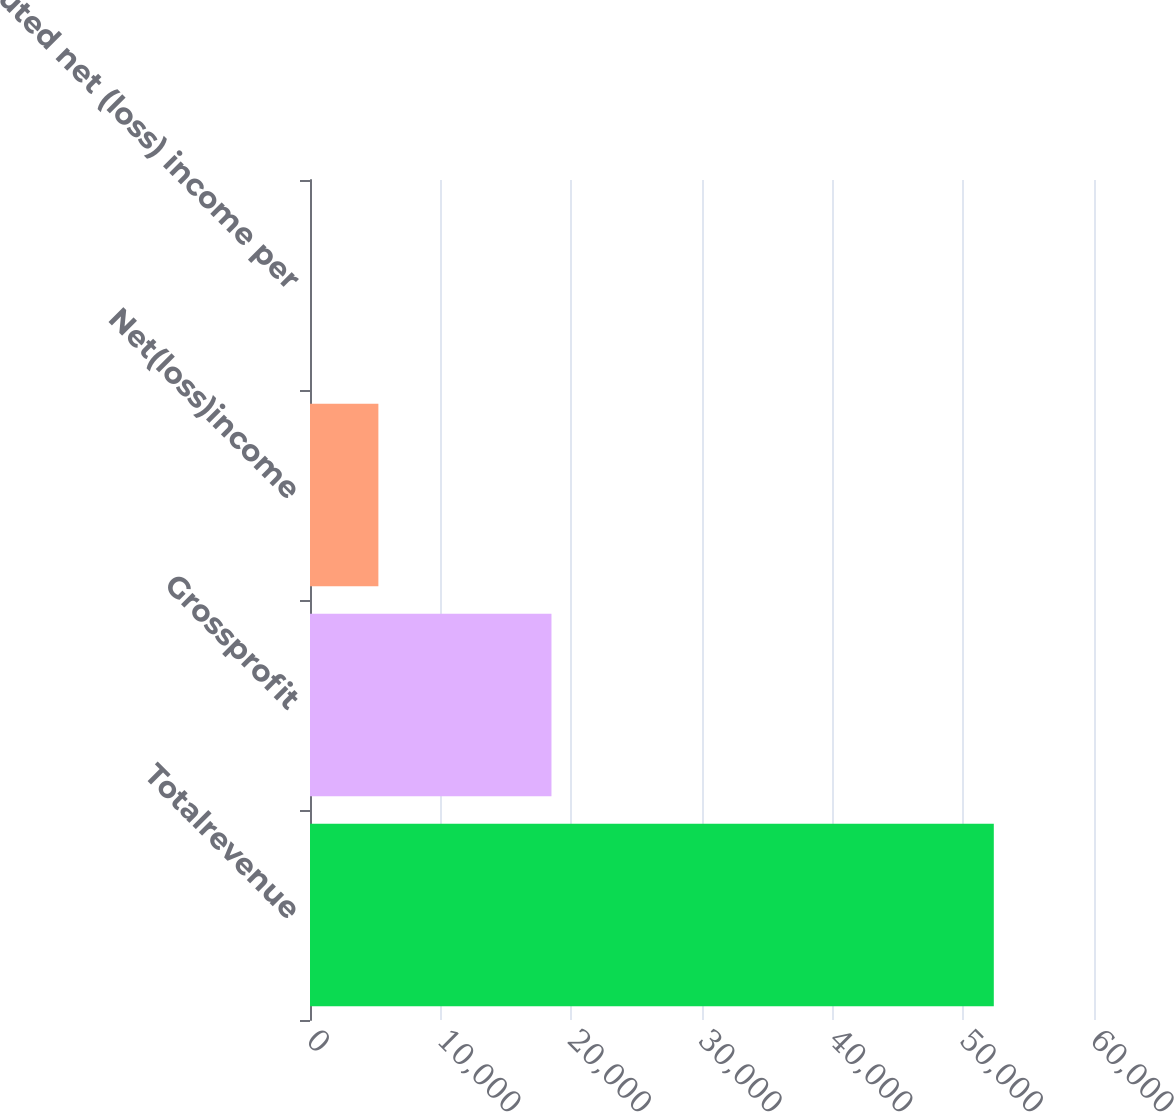Convert chart. <chart><loc_0><loc_0><loc_500><loc_500><bar_chart><fcel>Totalrevenue<fcel>Grossprofit<fcel>Net(loss)income<fcel>Diluted net (loss) income per<nl><fcel>52332<fcel>18480<fcel>5233.24<fcel>0.05<nl></chart> 